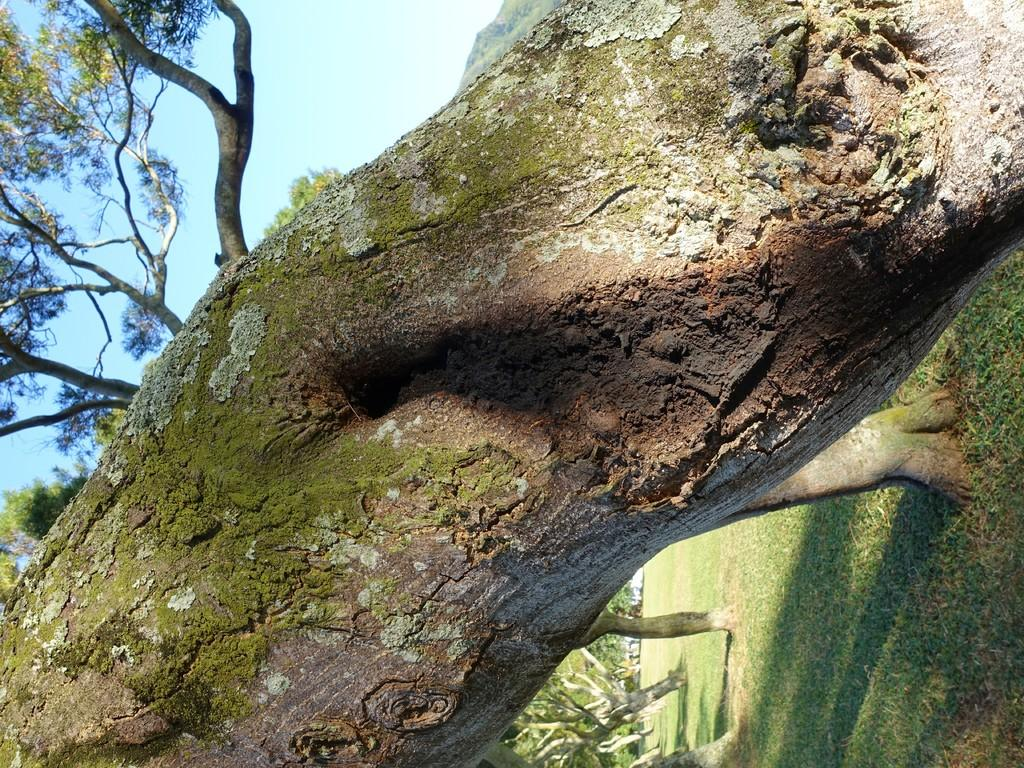What type of vegetation can be seen in the image? There are trees and grass in the image. Can you describe the natural setting in the image? The natural setting includes trees and grass. What type of box can be seen in the image? There is no box present in the image; it features in the image include trees and grass. Are there any pears visible in the image? There are no pears present in the image; the image features trees and grass. 